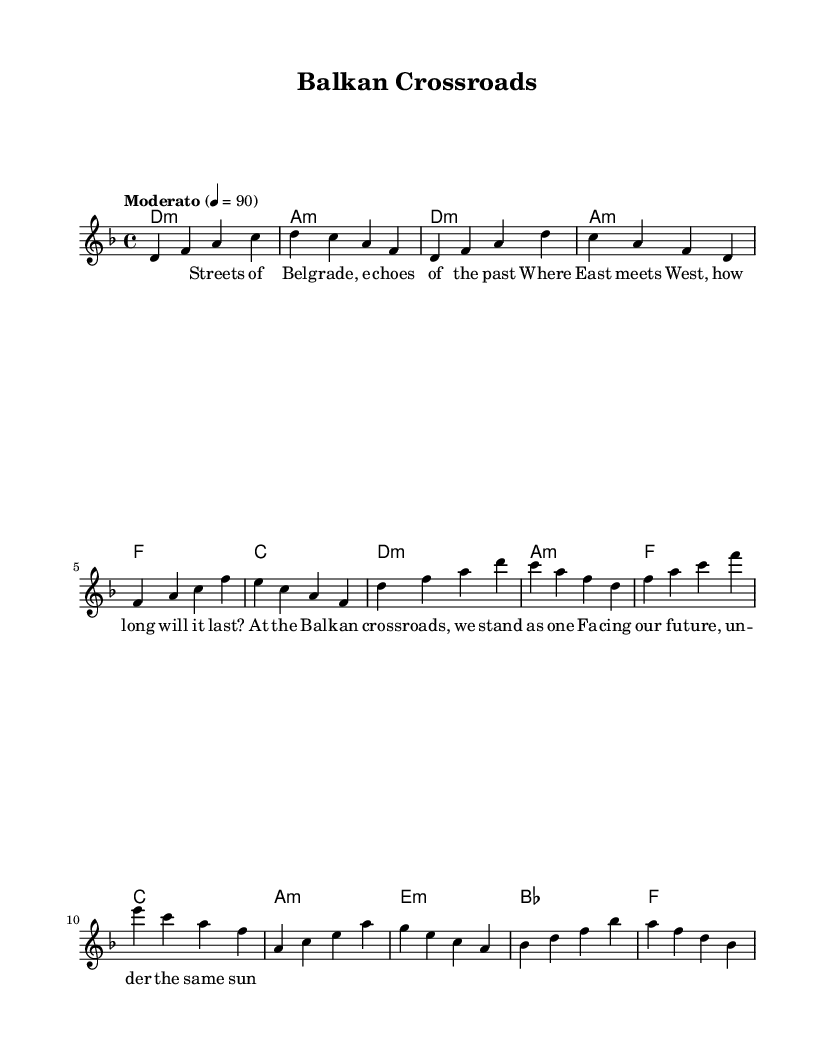What is the key signature of this music? The key signature is D minor, which typically features one flat (B flat) and is indicated at the beginning of the staff.
Answer: D minor What is the time signature of the piece? The time signature is indicated within the staff as 4/4, meaning there are four beats in each measure.
Answer: 4/4 What is the tempo marking given in the music? The tempo marking states "Moderato" and indicates a tempo of 90 beats per minute. This is commonly found at the start of the score.
Answer: Moderato What is the chord progression for the chorus section? Analyzing the chord names provided, the chorus has a repeating structure: D minor, A minor, F, and C. This sequence can be deduced from the chordmode section under the chorus label.
Answer: D minor, A minor, F, C How many measures are in the verse section? The verse section consists of four measures, as can be counted from the melody and harmony lines that correspond to that part of the song.
Answer: 4 According to the lyrics, what concept do the streets represent? The lyrics suggest that the "Streets of Belgrade" represent the historical blend of cultures indicated by the phrase "Where East meets West." This reflects the song's theme of unity and cultural intersection.
Answer: Unity What is the mood of the ballad suggested by the lyrics? The mood conveyed by the lyrics is reflective and hopeful, as they discuss facing the future together at the "Balkan crossroads." This interpretation can be drawn from the context and emotional undertones of the words.
Answer: Reflective 